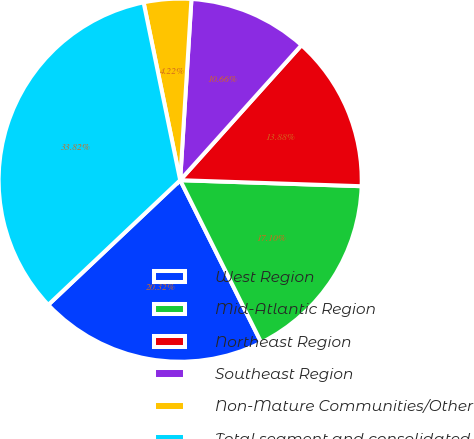<chart> <loc_0><loc_0><loc_500><loc_500><pie_chart><fcel>West Region<fcel>Mid-Atlantic Region<fcel>Northeast Region<fcel>Southeast Region<fcel>Non-Mature Communities/Other<fcel>Total segment and consolidated<nl><fcel>20.32%<fcel>17.1%<fcel>13.88%<fcel>10.66%<fcel>4.22%<fcel>33.82%<nl></chart> 